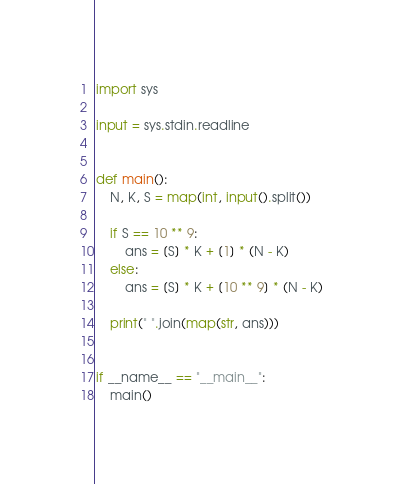Convert code to text. <code><loc_0><loc_0><loc_500><loc_500><_Python_>import sys

input = sys.stdin.readline


def main():
    N, K, S = map(int, input().split())

    if S == 10 ** 9:
        ans = [S] * K + [1] * (N - K)
    else:
        ans = [S] * K + [10 ** 9] * (N - K)

    print(" ".join(map(str, ans)))


if __name__ == "__main__":
    main()
</code> 